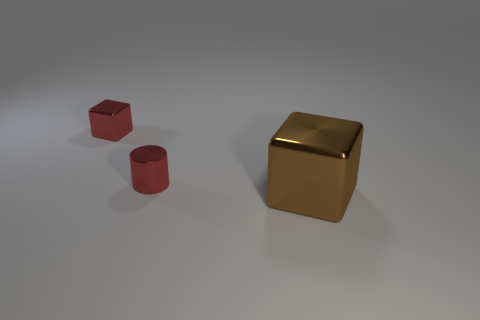Do the big brown block and the tiny object right of the small red block have the same material?
Ensure brevity in your answer.  Yes. The tiny cylinder in front of the cube left of the brown object is made of what material?
Offer a very short reply. Metal. Is the number of metal things that are in front of the large object greater than the number of large yellow rubber spheres?
Provide a short and direct response. No. Are any small red cubes visible?
Provide a short and direct response. Yes. The block to the left of the brown shiny block is what color?
Provide a short and direct response. Red. What is the material of the red cylinder that is the same size as the red block?
Offer a terse response. Metal. How many other things are there of the same material as the tiny red cylinder?
Offer a very short reply. 2. The metallic thing that is both right of the small metallic cube and behind the large object is what color?
Provide a succinct answer. Red. What number of things are either red metallic things that are on the right side of the red metal cube or small red objects?
Your answer should be compact. 2. How many other objects are the same color as the big shiny object?
Make the answer very short. 0. 